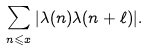Convert formula to latex. <formula><loc_0><loc_0><loc_500><loc_500>\sum _ { n \leqslant x } | \lambda ( n ) \lambda ( n + \ell ) | .</formula> 